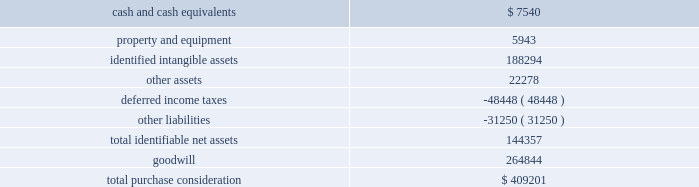Assets ( including trade receivables ) that are in the scope of the update .
Asu 2016-13 also made amendments to the current impairment model for held-to-maturity and available-for-sale debt securities and certain guarantees .
The guidance will become effective for us on january 1 , 2020 .
Early adoption is permitted for periods beginning on or after january 1 , 2019 .
We are evaluating the effect of asu 2016-13 on our consolidated financial statements .
Note 2 2014 acquisitions the transactions described below were accounted for as business combinations , which requires that we record the assets acquired and liabilities assumed at fair value as of the acquisition date .
On october 17 , 2018 , we acquired sicom systems , inc .
( 201csicom 201d ) for total purchase consideration of $ 409.2 million , which we funded with cash on hand and by drawing on our revolving credit facility ( described in 201cnote 8 2014 long-term debt and lines of credit 201d ) .
Sicom is a provider of end-to-end enterprise , cloud-based software solutions and other technologies to quick service restaurants and food service management companies .
Sicom 2019s technologies are complementary to our existing xenial solutions , and we believe this acquisition will expand our software-driven payments strategy by enabling us to increase our capabilities and expand on our existing presence in the restaurant vertical market .
Prior to the acquisition , sicom was indirectly owned by a private equity investment firm where one of our board members is a partner and investor .
His direct interest in the transaction was approximately $ 1.1 million , the amount distributed to him based on his investment interest in the fund of the private equity firm that sold sicom to us .
Based on consideration of all relevant information , the audit committee of our board of directors recommended that the board approve the acquisition of sicom , which it did .
The provisional estimated acquisition-date fair values of major classes of assets acquired and liabilities assumed as of december 31 , 2018 , including a reconciliation to the total purchase consideration , were as follows ( in thousands ) : .
As of december 31 , 2018 , we considered these balances to be provisional because we were still in the process of determining the final purchase consideration , which is subject to adjustment pursuant to the purchase agreement , and gathering and reviewing information to support the valuations of the assets acquired and liabilities assumed .
Goodwill arising from the acquisition of $ 264.8 million , included in the north america segment , was attributable to expected growth opportunities , an assembled workforce and potential synergies from combining our existing businesses .
We expect that approximately $ 50 million of the goodwill from this acquisition will be deductible for income tax purposes .
74 2013 global payments inc .
| 2018 form 10-k annual report .
What is the percent of assets are definitive net assets? 
Rationale: the assets that are definitive are tangible therefore goodwill and intangible assets are not considered definitive assets . therefore to figure out the percentage of definitive assets , one must added up all the assets and divide the tangible assets by the total assets .
Computations: (144357 / (144357 + (264844 + 188294)))
Answer: 0.2416. Assets ( including trade receivables ) that are in the scope of the update .
Asu 2016-13 also made amendments to the current impairment model for held-to-maturity and available-for-sale debt securities and certain guarantees .
The guidance will become effective for us on january 1 , 2020 .
Early adoption is permitted for periods beginning on or after january 1 , 2019 .
We are evaluating the effect of asu 2016-13 on our consolidated financial statements .
Note 2 2014 acquisitions the transactions described below were accounted for as business combinations , which requires that we record the assets acquired and liabilities assumed at fair value as of the acquisition date .
On october 17 , 2018 , we acquired sicom systems , inc .
( 201csicom 201d ) for total purchase consideration of $ 409.2 million , which we funded with cash on hand and by drawing on our revolving credit facility ( described in 201cnote 8 2014 long-term debt and lines of credit 201d ) .
Sicom is a provider of end-to-end enterprise , cloud-based software solutions and other technologies to quick service restaurants and food service management companies .
Sicom 2019s technologies are complementary to our existing xenial solutions , and we believe this acquisition will expand our software-driven payments strategy by enabling us to increase our capabilities and expand on our existing presence in the restaurant vertical market .
Prior to the acquisition , sicom was indirectly owned by a private equity investment firm where one of our board members is a partner and investor .
His direct interest in the transaction was approximately $ 1.1 million , the amount distributed to him based on his investment interest in the fund of the private equity firm that sold sicom to us .
Based on consideration of all relevant information , the audit committee of our board of directors recommended that the board approve the acquisition of sicom , which it did .
The provisional estimated acquisition-date fair values of major classes of assets acquired and liabilities assumed as of december 31 , 2018 , including a reconciliation to the total purchase consideration , were as follows ( in thousands ) : .
As of december 31 , 2018 , we considered these balances to be provisional because we were still in the process of determining the final purchase consideration , which is subject to adjustment pursuant to the purchase agreement , and gathering and reviewing information to support the valuations of the assets acquired and liabilities assumed .
Goodwill arising from the acquisition of $ 264.8 million , included in the north america segment , was attributable to expected growth opportunities , an assembled workforce and potential synergies from combining our existing businesses .
We expect that approximately $ 50 million of the goodwill from this acquisition will be deductible for income tax purposes .
74 2013 global payments inc .
| 2018 form 10-k annual report .
What are the total assets repoert? 
Computations: (((7540 + 5943) + 188294) + 22278)
Answer: 224055.0. Assets ( including trade receivables ) that are in the scope of the update .
Asu 2016-13 also made amendments to the current impairment model for held-to-maturity and available-for-sale debt securities and certain guarantees .
The guidance will become effective for us on january 1 , 2020 .
Early adoption is permitted for periods beginning on or after january 1 , 2019 .
We are evaluating the effect of asu 2016-13 on our consolidated financial statements .
Note 2 2014 acquisitions the transactions described below were accounted for as business combinations , which requires that we record the assets acquired and liabilities assumed at fair value as of the acquisition date .
On october 17 , 2018 , we acquired sicom systems , inc .
( 201csicom 201d ) for total purchase consideration of $ 409.2 million , which we funded with cash on hand and by drawing on our revolving credit facility ( described in 201cnote 8 2014 long-term debt and lines of credit 201d ) .
Sicom is a provider of end-to-end enterprise , cloud-based software solutions and other technologies to quick service restaurants and food service management companies .
Sicom 2019s technologies are complementary to our existing xenial solutions , and we believe this acquisition will expand our software-driven payments strategy by enabling us to increase our capabilities and expand on our existing presence in the restaurant vertical market .
Prior to the acquisition , sicom was indirectly owned by a private equity investment firm where one of our board members is a partner and investor .
His direct interest in the transaction was approximately $ 1.1 million , the amount distributed to him based on his investment interest in the fund of the private equity firm that sold sicom to us .
Based on consideration of all relevant information , the audit committee of our board of directors recommended that the board approve the acquisition of sicom , which it did .
The provisional estimated acquisition-date fair values of major classes of assets acquired and liabilities assumed as of december 31 , 2018 , including a reconciliation to the total purchase consideration , were as follows ( in thousands ) : .
As of december 31 , 2018 , we considered these balances to be provisional because we were still in the process of determining the final purchase consideration , which is subject to adjustment pursuant to the purchase agreement , and gathering and reviewing information to support the valuations of the assets acquired and liabilities assumed .
Goodwill arising from the acquisition of $ 264.8 million , included in the north america segment , was attributable to expected growth opportunities , an assembled workforce and potential synergies from combining our existing businesses .
We expect that approximately $ 50 million of the goodwill from this acquisition will be deductible for income tax purposes .
74 2013 global payments inc .
| 2018 form 10-k annual report .
What was the total percentage of costs that came from identifiable assets? 
Rationale: to find out the identifiable assets one must not include goodwill . therefore to figure out the answer , one will take the total amount and subtract goodwill .
Computations: (409201 - 264844)
Answer: 144357.0. Assets ( including trade receivables ) that are in the scope of the update .
Asu 2016-13 also made amendments to the current impairment model for held-to-maturity and available-for-sale debt securities and certain guarantees .
The guidance will become effective for us on january 1 , 2020 .
Early adoption is permitted for periods beginning on or after january 1 , 2019 .
We are evaluating the effect of asu 2016-13 on our consolidated financial statements .
Note 2 2014 acquisitions the transactions described below were accounted for as business combinations , which requires that we record the assets acquired and liabilities assumed at fair value as of the acquisition date .
On october 17 , 2018 , we acquired sicom systems , inc .
( 201csicom 201d ) for total purchase consideration of $ 409.2 million , which we funded with cash on hand and by drawing on our revolving credit facility ( described in 201cnote 8 2014 long-term debt and lines of credit 201d ) .
Sicom is a provider of end-to-end enterprise , cloud-based software solutions and other technologies to quick service restaurants and food service management companies .
Sicom 2019s technologies are complementary to our existing xenial solutions , and we believe this acquisition will expand our software-driven payments strategy by enabling us to increase our capabilities and expand on our existing presence in the restaurant vertical market .
Prior to the acquisition , sicom was indirectly owned by a private equity investment firm where one of our board members is a partner and investor .
His direct interest in the transaction was approximately $ 1.1 million , the amount distributed to him based on his investment interest in the fund of the private equity firm that sold sicom to us .
Based on consideration of all relevant information , the audit committee of our board of directors recommended that the board approve the acquisition of sicom , which it did .
The provisional estimated acquisition-date fair values of major classes of assets acquired and liabilities assumed as of december 31 , 2018 , including a reconciliation to the total purchase consideration , were as follows ( in thousands ) : .
As of december 31 , 2018 , we considered these balances to be provisional because we were still in the process of determining the final purchase consideration , which is subject to adjustment pursuant to the purchase agreement , and gathering and reviewing information to support the valuations of the assets acquired and liabilities assumed .
Goodwill arising from the acquisition of $ 264.8 million , included in the north america segment , was attributable to expected growth opportunities , an assembled workforce and potential synergies from combining our existing businesses .
We expect that approximately $ 50 million of the goodwill from this acquisition will be deductible for income tax purposes .
74 2013 global payments inc .
| 2018 form 10-k annual report .
What percentage of total purchase consideration is composed of goodwill? 
Computations: (264844 / 409201)
Answer: 0.64722. 